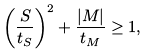Convert formula to latex. <formula><loc_0><loc_0><loc_500><loc_500>\left ( \frac { S } { t _ { S } } \right ) ^ { 2 } + \frac { | M | } { t _ { M } } \geq 1 ,</formula> 